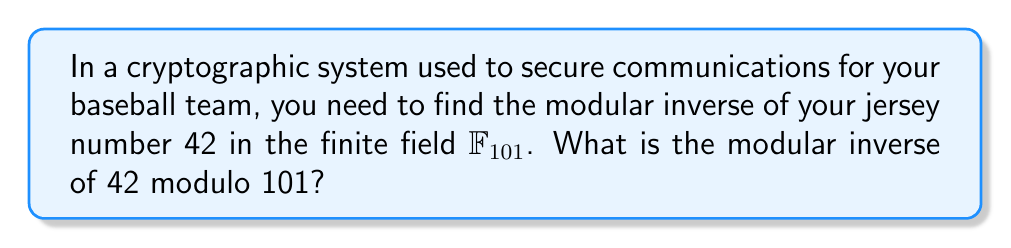Can you solve this math problem? To find the modular inverse of 42 modulo 101, we need to find a number $x$ such that:

$$(42 \cdot x) \equiv 1 \pmod{101}$$

We can use the extended Euclidean algorithm to find this value:

1) Start with the equation: $101 = 2 \cdot 42 + 17$
2) Then: $42 = 2 \cdot 17 + 8$
3) $17 = 2 \cdot 8 + 1$
4) $8 = 8 \cdot 1 + 0$

Now we work backwards:

$1 = 17 - 2 \cdot 8$
$1 = 17 - 2 \cdot (42 - 2 \cdot 17) = 5 \cdot 17 - 2 \cdot 42$
$1 = 5 \cdot (101 - 2 \cdot 42) - 2 \cdot 42 = 5 \cdot 101 - 12 \cdot 42$

Therefore, $-12 \cdot 42 \equiv 1 \pmod{101}$

The smallest positive number congruent to -12 modulo 101 is 89.

Thus, $89 \cdot 42 \equiv 1 \pmod{101}$

We can verify: $89 \cdot 42 = 3738 \equiv 1 \pmod{101}$
Answer: 89 